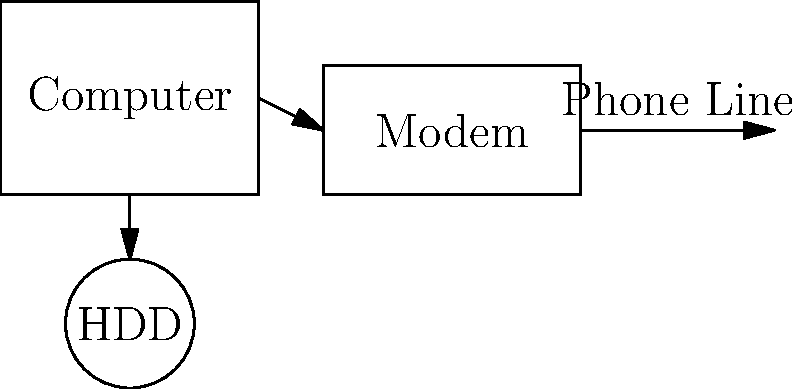In the diagram above, which component connects the BBS computer to the outside world, allowing users to dial in? To answer this question, let's analyze the components in the diagram:

1. We see a computer, which is the main unit running the BBS software.
2. There's a hard drive (HDD) connected to the computer, likely storing the BBS data and software.
3. A modem is depicted, connected to the computer.
4. The modem is shown connected to a phone line.

The key to understanding how users connect to the BBS lies in identifying the component that interfaces between the computer and the telephone network. In this setup, that component is the modem.

Modems (MOdulator-DEModulator) were crucial for BBS systems in the 90s because they:

1. Converted digital signals from the computer into analog signals that could be transmitted over phone lines.
2. Converted incoming analog signals from the phone line back into digital signals the computer could understand.

This allowed BBS users to dial in using their own modems and computers, connecting to the BBS over standard telephone lines.

Therefore, the modem is the component that connects the BBS computer to the outside world, enabling users to dial in and access the BBS.
Answer: Modem 